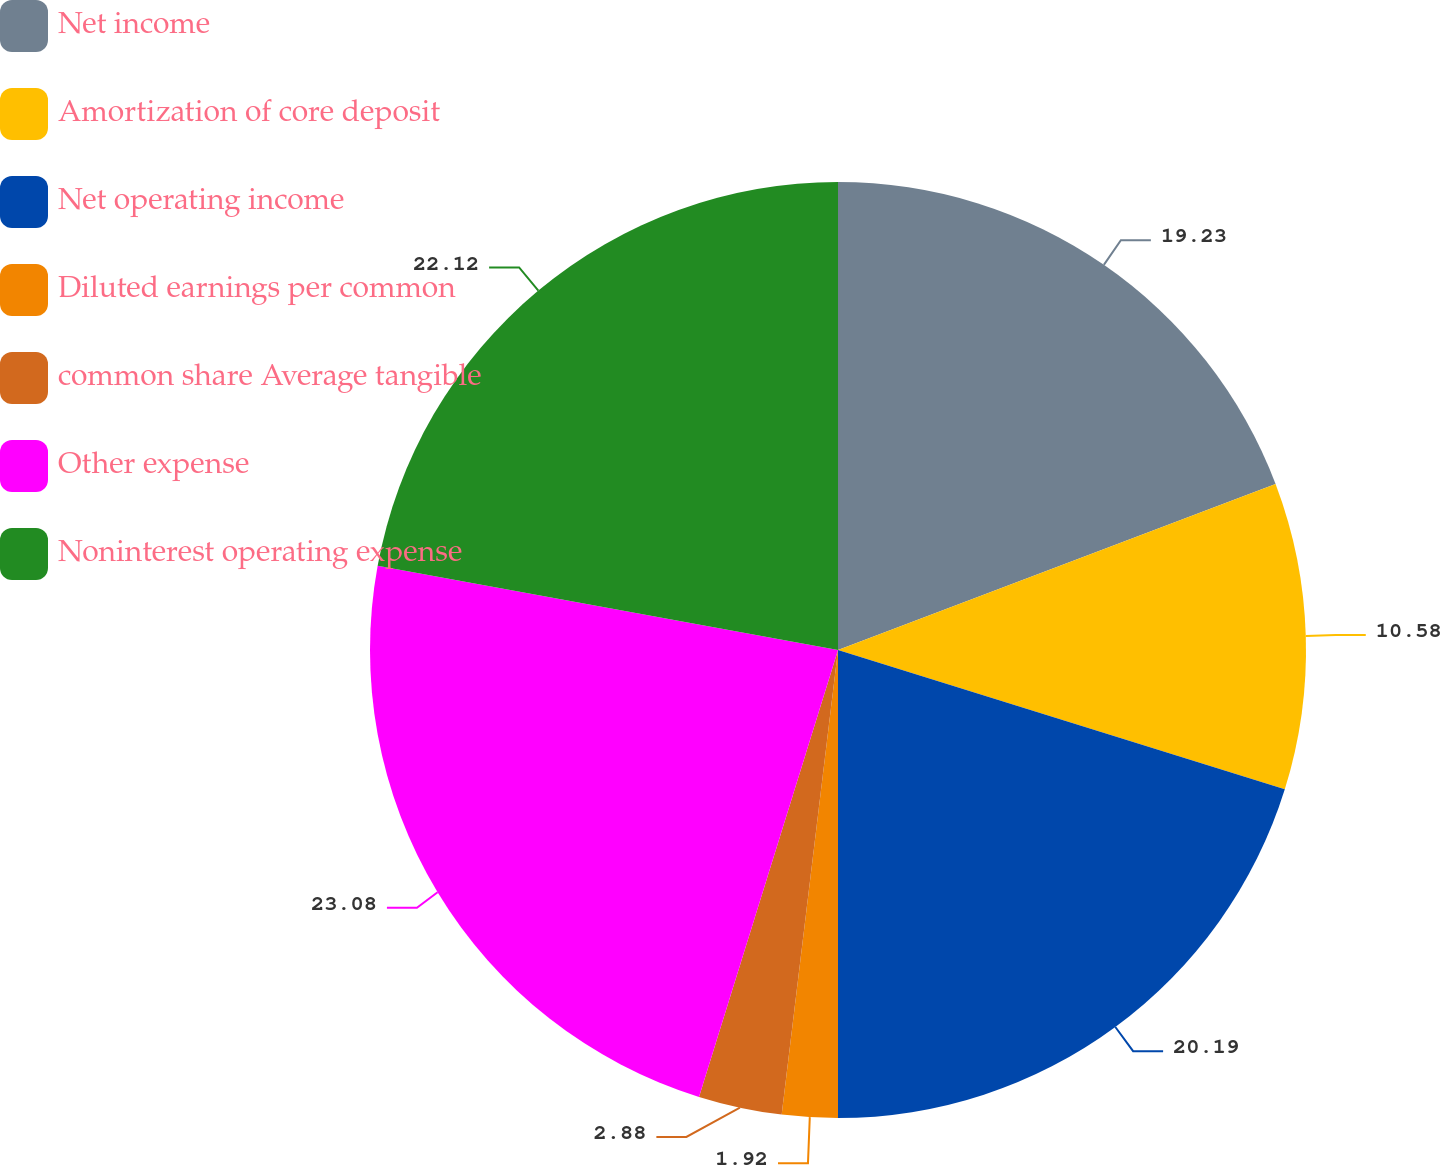Convert chart to OTSL. <chart><loc_0><loc_0><loc_500><loc_500><pie_chart><fcel>Net income<fcel>Amortization of core deposit<fcel>Net operating income<fcel>Diluted earnings per common<fcel>common share Average tangible<fcel>Other expense<fcel>Noninterest operating expense<nl><fcel>19.23%<fcel>10.58%<fcel>20.19%<fcel>1.92%<fcel>2.88%<fcel>23.08%<fcel>22.12%<nl></chart> 